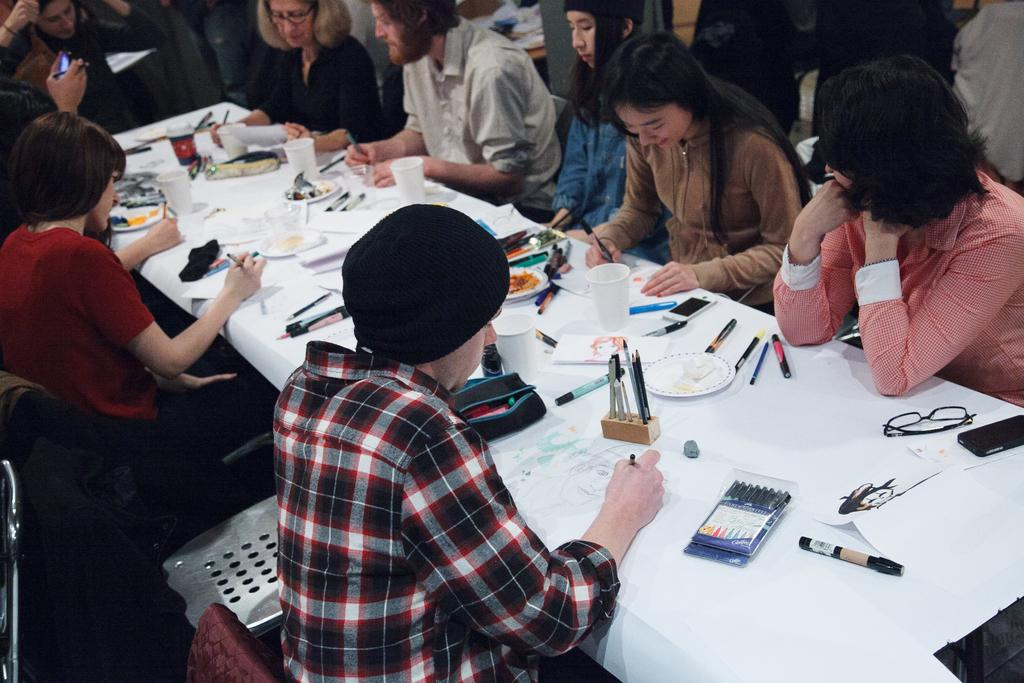What are the people in the image doing? The people in the image are sitting on chairs. What is in front of the people? There is a table in front of the people. What can be seen on the table? There are multiple items on the table. What type of record is being played on the table in the image? There is no record or record player present in the image. 